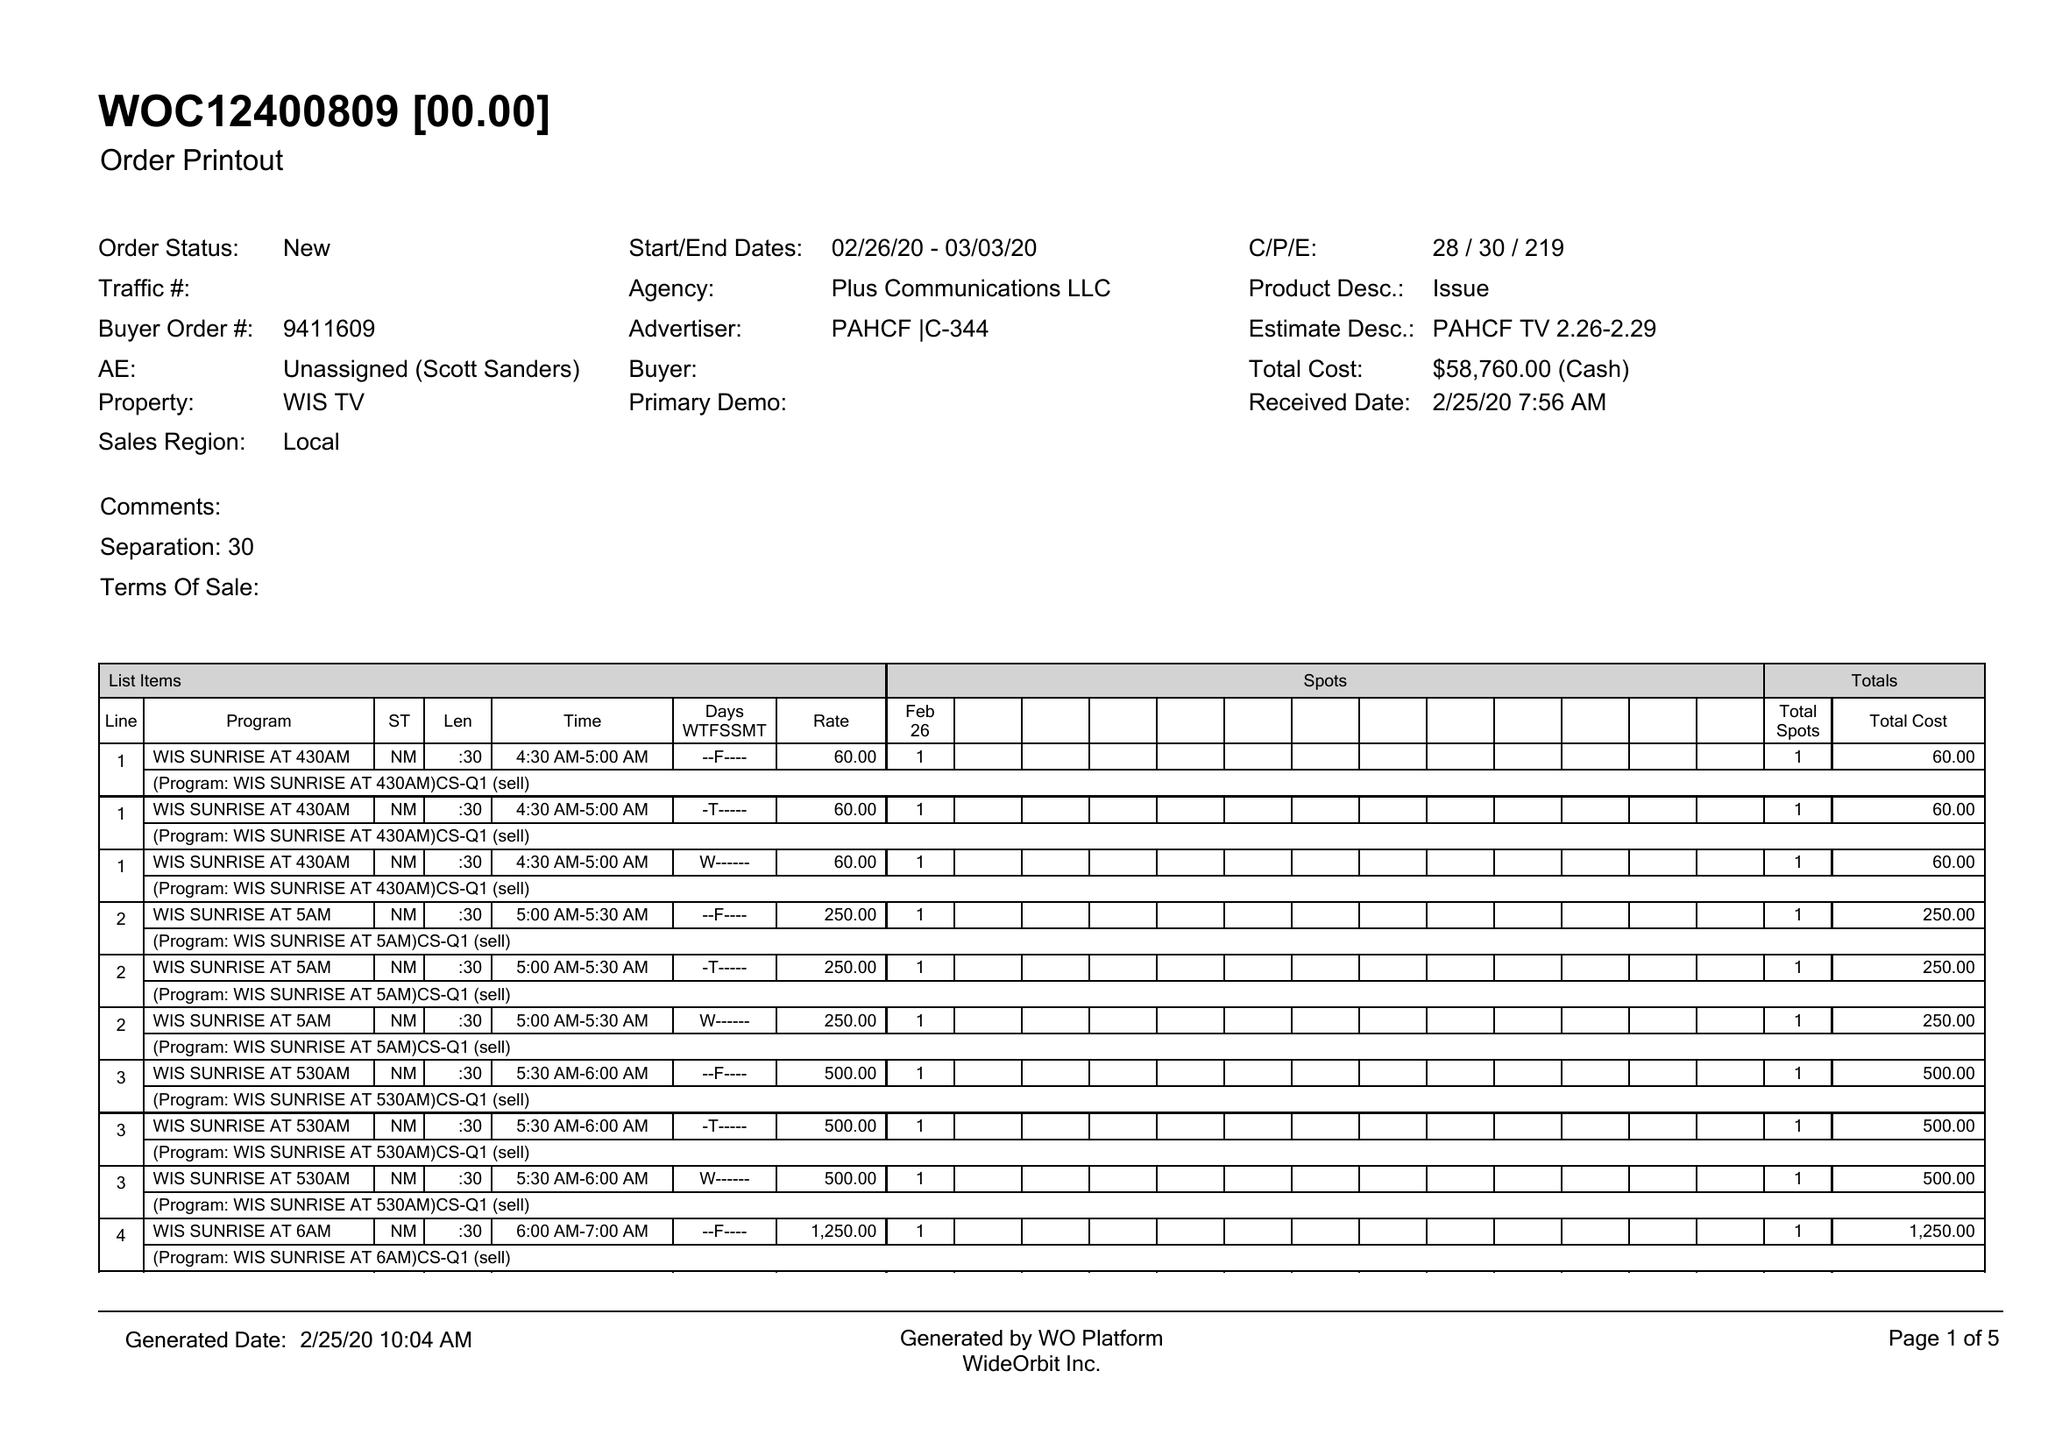What is the value for the gross_amount?
Answer the question using a single word or phrase. 58760.00 